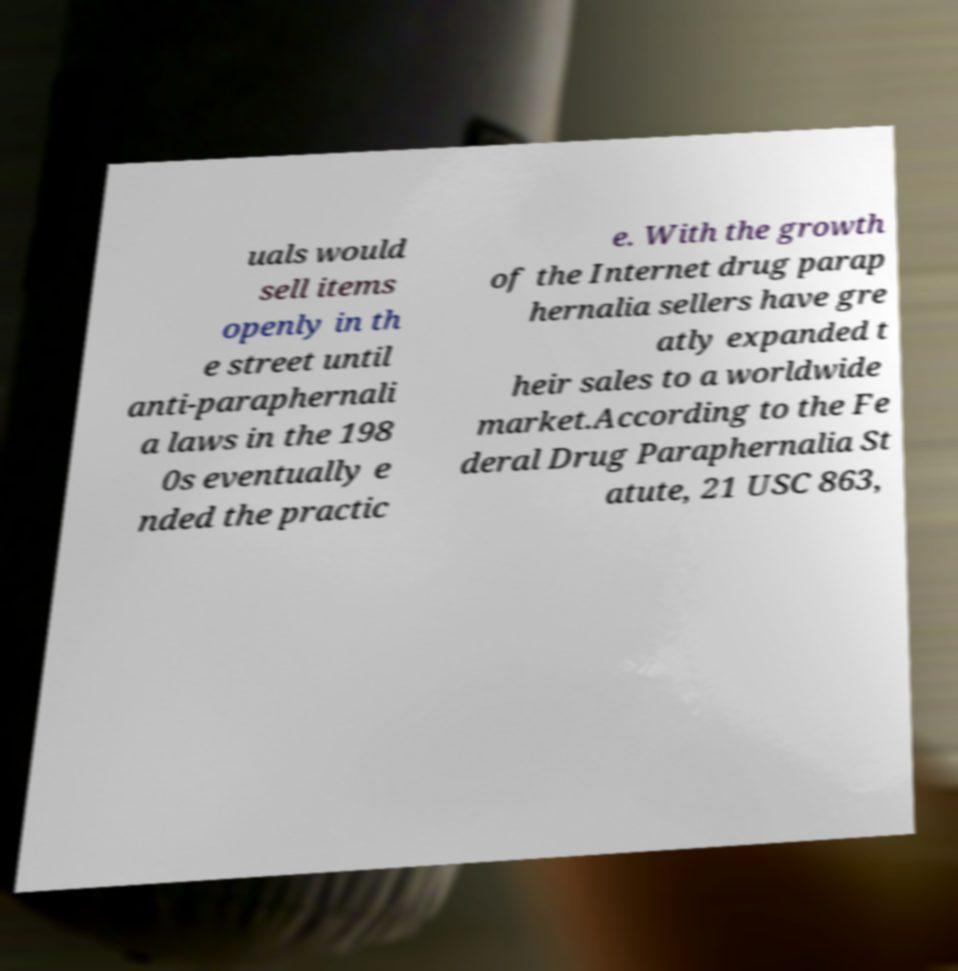Can you read and provide the text displayed in the image?This photo seems to have some interesting text. Can you extract and type it out for me? uals would sell items openly in th e street until anti-paraphernali a laws in the 198 0s eventually e nded the practic e. With the growth of the Internet drug parap hernalia sellers have gre atly expanded t heir sales to a worldwide market.According to the Fe deral Drug Paraphernalia St atute, 21 USC 863, 